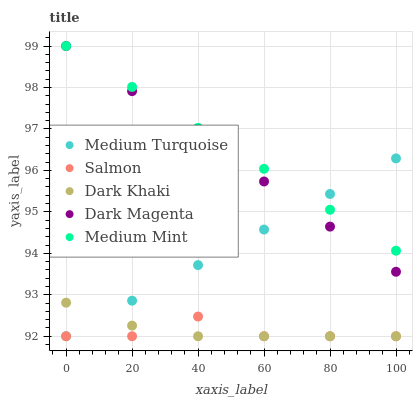Does Salmon have the minimum area under the curve?
Answer yes or no. Yes. Does Medium Mint have the maximum area under the curve?
Answer yes or no. Yes. Does Medium Mint have the minimum area under the curve?
Answer yes or no. No. Does Salmon have the maximum area under the curve?
Answer yes or no. No. Is Medium Mint the smoothest?
Answer yes or no. Yes. Is Salmon the roughest?
Answer yes or no. Yes. Is Salmon the smoothest?
Answer yes or no. No. Is Medium Mint the roughest?
Answer yes or no. No. Does Dark Khaki have the lowest value?
Answer yes or no. Yes. Does Medium Mint have the lowest value?
Answer yes or no. No. Does Dark Magenta have the highest value?
Answer yes or no. Yes. Does Salmon have the highest value?
Answer yes or no. No. Is Dark Khaki less than Dark Magenta?
Answer yes or no. Yes. Is Dark Magenta greater than Salmon?
Answer yes or no. Yes. Does Dark Magenta intersect Medium Mint?
Answer yes or no. Yes. Is Dark Magenta less than Medium Mint?
Answer yes or no. No. Is Dark Magenta greater than Medium Mint?
Answer yes or no. No. Does Dark Khaki intersect Dark Magenta?
Answer yes or no. No. 